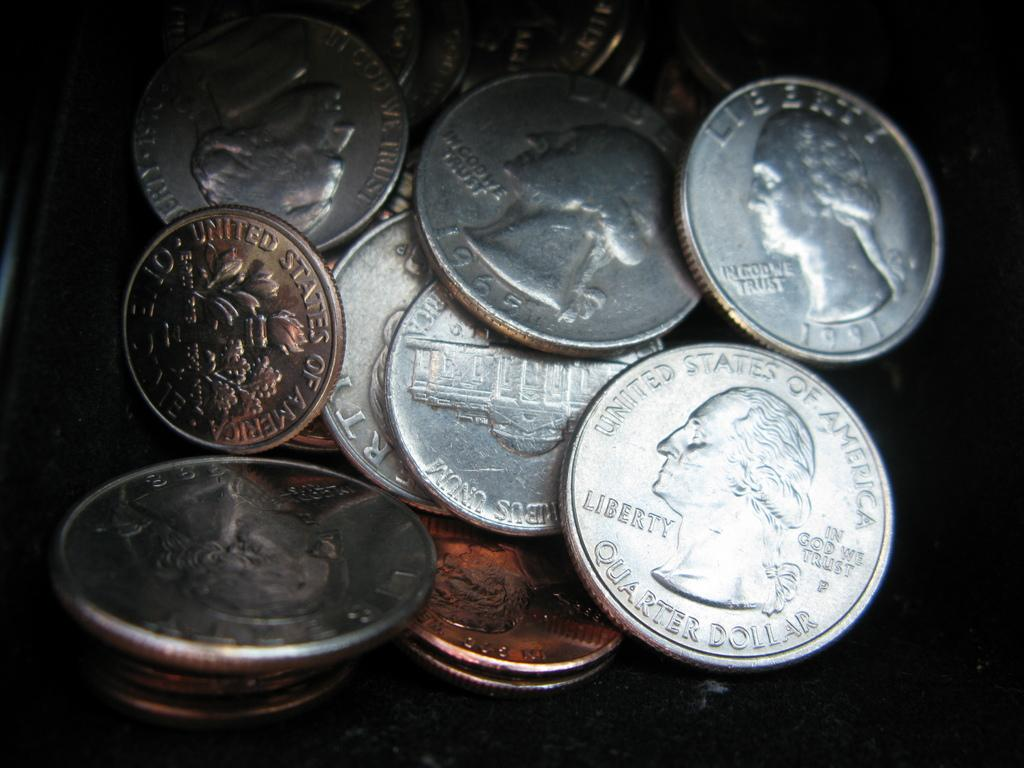<image>
Describe the image concisely. a stack of coins with quarters that say 'united states of america' on them 